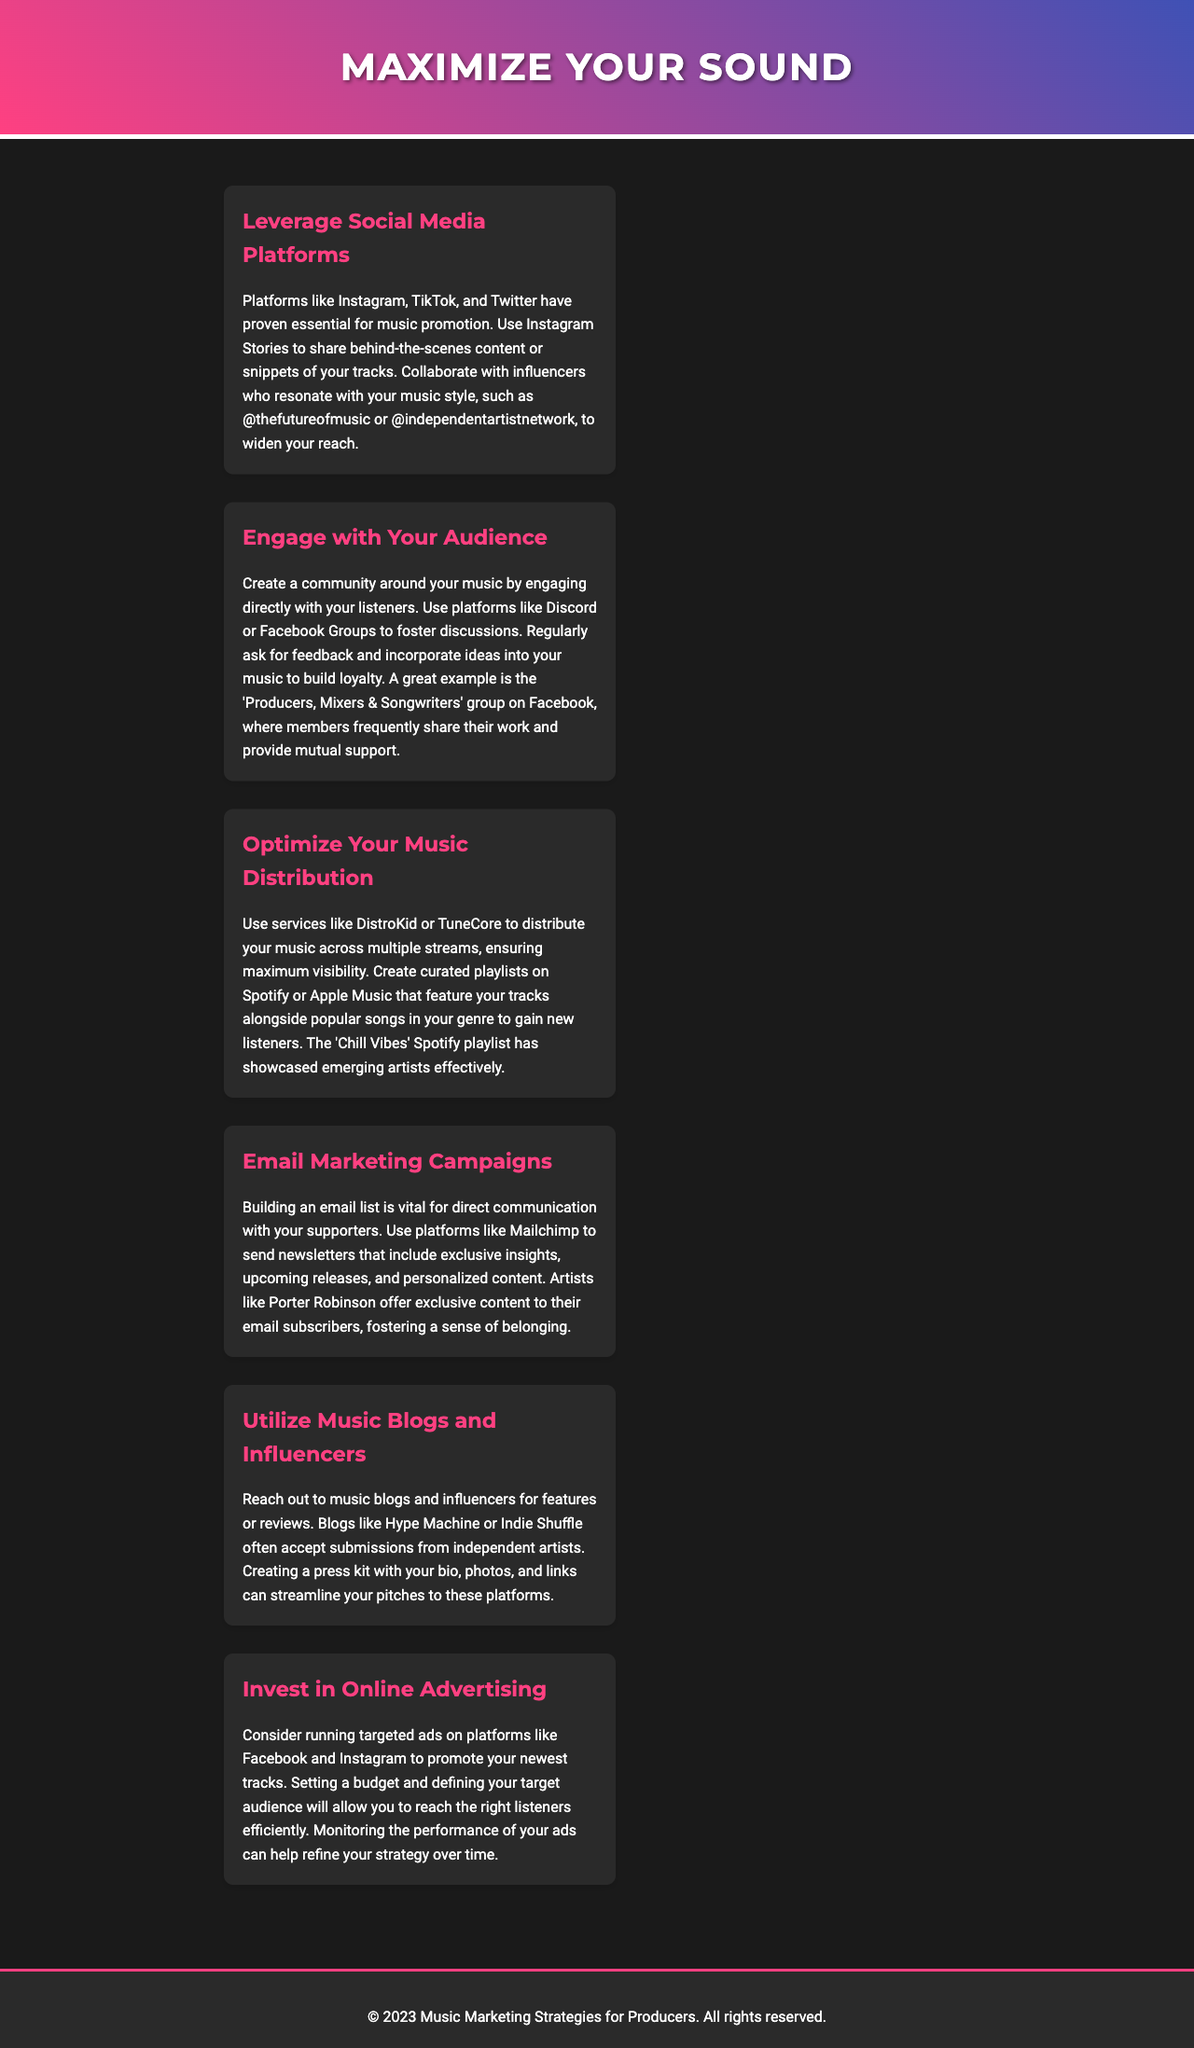What are essential platforms for music promotion? The document highlights platforms like Instagram, TikTok, and Twitter as essential for music promotion.
Answer: Instagram, TikTok, Twitter What is a method to foster community engagement? The document suggests using platforms like Discord or Facebook Groups for community engagement with listeners.
Answer: Discord, Facebook Groups What service can be used for music distribution? The document mentions services like DistroKid or TuneCore for music distribution.
Answer: DistroKid, TuneCore What is a benefit of building an email list? The document states that an email list allows for direct communication with supporters.
Answer: Direct communication Which music blogs are mentioned for submission opportunities? The document refers to blogs like Hype Machine or Indie Shuffle for submission opportunities.
Answer: Hype Machine, Indie Shuffle What is a strategy for promoting tracks effectively? The document suggests running targeted ads on platforms like Facebook and Instagram as a strategy for promotion.
Answer: Targeted ads What is a featured example for community support? The document cites the 'Producers, Mixers & Songwriters' group on Facebook as a featured example for community support.
Answer: Producers, Mixers & Songwriters What is the title of the newsletter? The document's title is indicated as "Maximize Your Sound".
Answer: Maximize Your Sound 